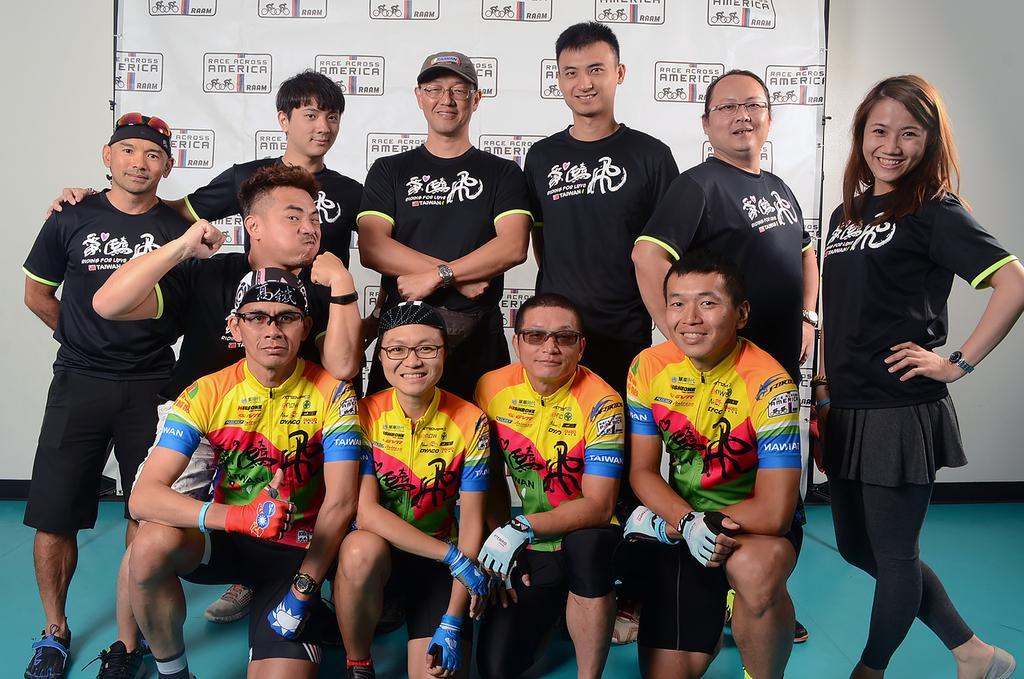Can you describe this image briefly? This picture describes about group of people, few people wore black color T-shirts and spectacles, in the background we can see a hoarding. 